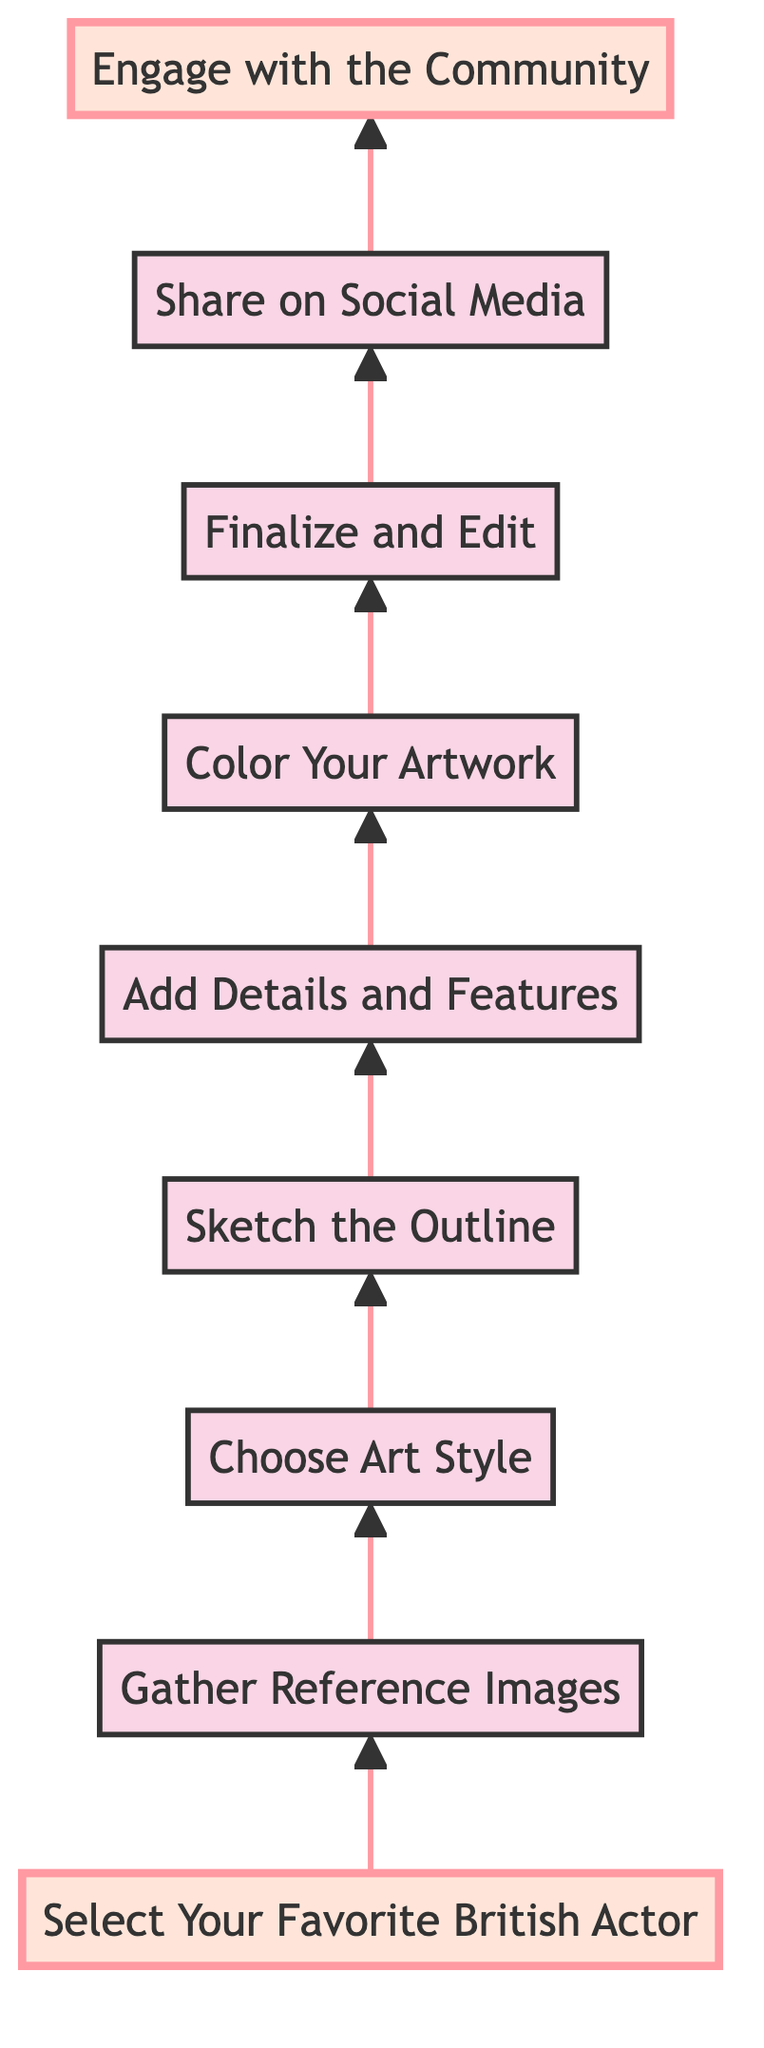What is the first step in the process? The diagram indicates that the first step is "Select Your Favorite British Actor," which is the bottommost node.
Answer: Select Your Favorite British Actor How many total steps are there? By counting the nodes in the diagram, there are a total of nine steps that lead upwards, from the initial selection to community engagement.
Answer: Nine What is the last step in the process? The last step at the top of the diagram is "Engage with the Community," which signifies the culmination of the fan art creation journey.
Answer: Engage with the Community Which step comes immediately after "Color Your Artwork"? Looking at the flow of the diagram, the step that follows "Color Your Artwork" is "Finalize and Edit," which shows the next action to take.
Answer: Finalize and Edit What is the relationship between "Sketch the Outline" and "Add Details and Features"? The diagram illustrates a direct progression where "Sketch the Outline" leads to "Add Details and Features," indicating that after sketching, you need to add details.
Answer: Direct progression Which step is highlighted in the diagram? The highlighted steps in the diagram are "Select Your Favorite British Actor" at the beginning and "Engage with the Community" at the end, emphasizing their significance.
Answer: Select Your Favorite British Actor and Engage with the Community How many nodes are before "Share on Social Media"? To find how many nodes come before "Share on Social Media," one can trace backwards from that node, counting four preceding steps: "Finalize and Edit," "Color Your Artwork," "Add Details and Features," and "Sketch the Outline."
Answer: Four What would you do after "Gather Reference Images"? Following the flow, after "Gather Reference Images," the next action is to "Choose Art Style," indicating what to consider next.
Answer: Choose Art Style Where does "Choose Art Style" rank in the sequence? In the sequence of steps, "Choose Art Style" ranks as the third step from the bottom, after selecting an actor and gathering images.
Answer: Third 